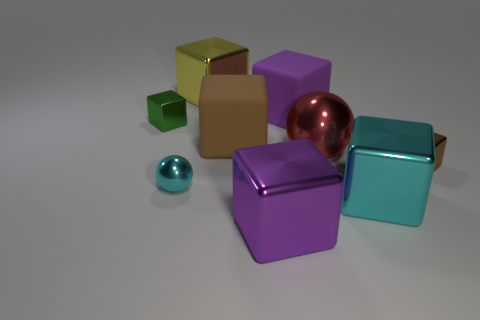How many things are small brown cubes or small spheres?
Your answer should be very brief. 2. What is the size of the purple object in front of the brown metal object in front of the ball that is to the right of the large brown matte cube?
Make the answer very short. Large. How many large things have the same color as the small sphere?
Your answer should be compact. 1. What number of tiny cubes are made of the same material as the red thing?
Provide a succinct answer. 2. How many things are either small blocks or large purple objects in front of the tiny cyan metallic object?
Ensure brevity in your answer.  3. What color is the tiny block that is behind the tiny metallic cube that is right of the purple metallic thing that is in front of the big brown object?
Provide a short and direct response. Green. There is a metallic ball that is to the left of the red sphere; how big is it?
Your response must be concise. Small. How many big objects are either rubber things or metallic spheres?
Your answer should be very brief. 3. There is a large shiny cube that is both on the left side of the purple rubber cube and in front of the large brown rubber thing; what color is it?
Offer a terse response. Purple. Is there a tiny blue shiny thing that has the same shape as the big brown rubber thing?
Ensure brevity in your answer.  No. 